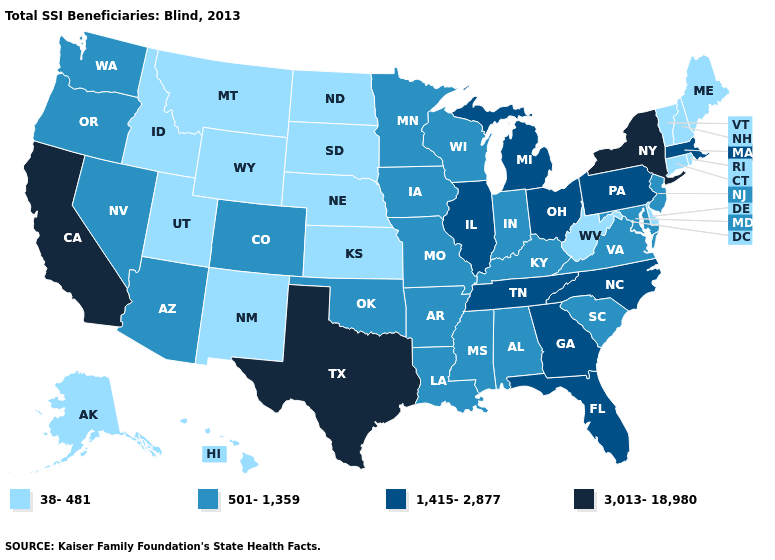Name the states that have a value in the range 1,415-2,877?
Short answer required. Florida, Georgia, Illinois, Massachusetts, Michigan, North Carolina, Ohio, Pennsylvania, Tennessee. What is the value of Tennessee?
Quick response, please. 1,415-2,877. What is the lowest value in the USA?
Short answer required. 38-481. What is the value of Minnesota?
Be succinct. 501-1,359. What is the value of Georgia?
Keep it brief. 1,415-2,877. Name the states that have a value in the range 1,415-2,877?
Give a very brief answer. Florida, Georgia, Illinois, Massachusetts, Michigan, North Carolina, Ohio, Pennsylvania, Tennessee. What is the value of New York?
Write a very short answer. 3,013-18,980. Among the states that border Nebraska , which have the highest value?
Short answer required. Colorado, Iowa, Missouri. Name the states that have a value in the range 38-481?
Keep it brief. Alaska, Connecticut, Delaware, Hawaii, Idaho, Kansas, Maine, Montana, Nebraska, New Hampshire, New Mexico, North Dakota, Rhode Island, South Dakota, Utah, Vermont, West Virginia, Wyoming. What is the lowest value in states that border Virginia?
Give a very brief answer. 38-481. Name the states that have a value in the range 501-1,359?
Write a very short answer. Alabama, Arizona, Arkansas, Colorado, Indiana, Iowa, Kentucky, Louisiana, Maryland, Minnesota, Mississippi, Missouri, Nevada, New Jersey, Oklahoma, Oregon, South Carolina, Virginia, Washington, Wisconsin. What is the highest value in the USA?
Give a very brief answer. 3,013-18,980. Name the states that have a value in the range 3,013-18,980?
Answer briefly. California, New York, Texas. What is the value of California?
Be succinct. 3,013-18,980. What is the lowest value in states that border North Carolina?
Short answer required. 501-1,359. 